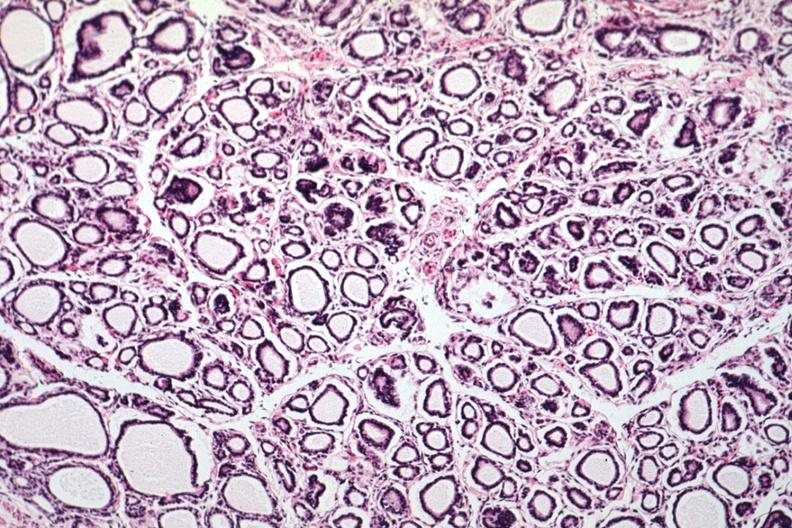s granulomata slide present?
Answer the question using a single word or phrase. No 